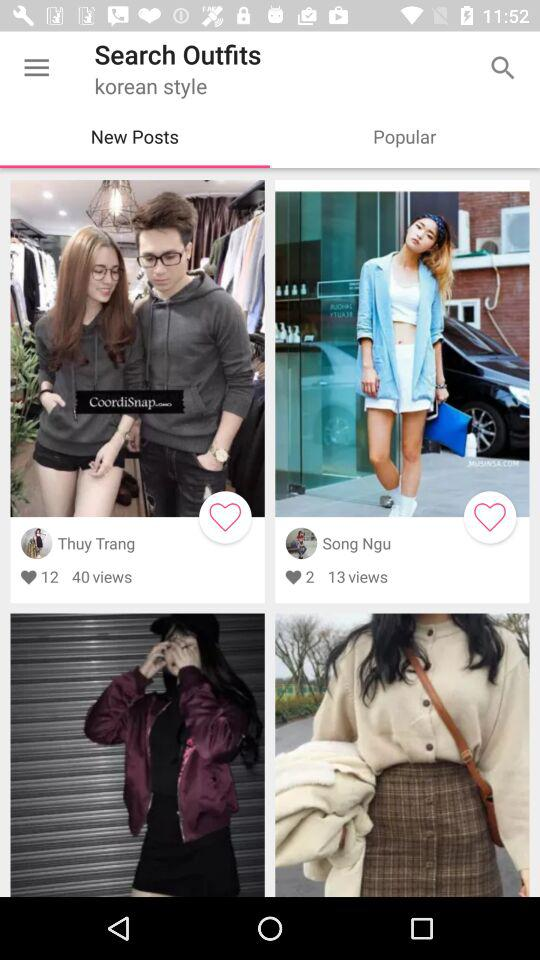How many people viewed the Thuy Trang post? The Thuy Trang Post was viewed by 40 people. 